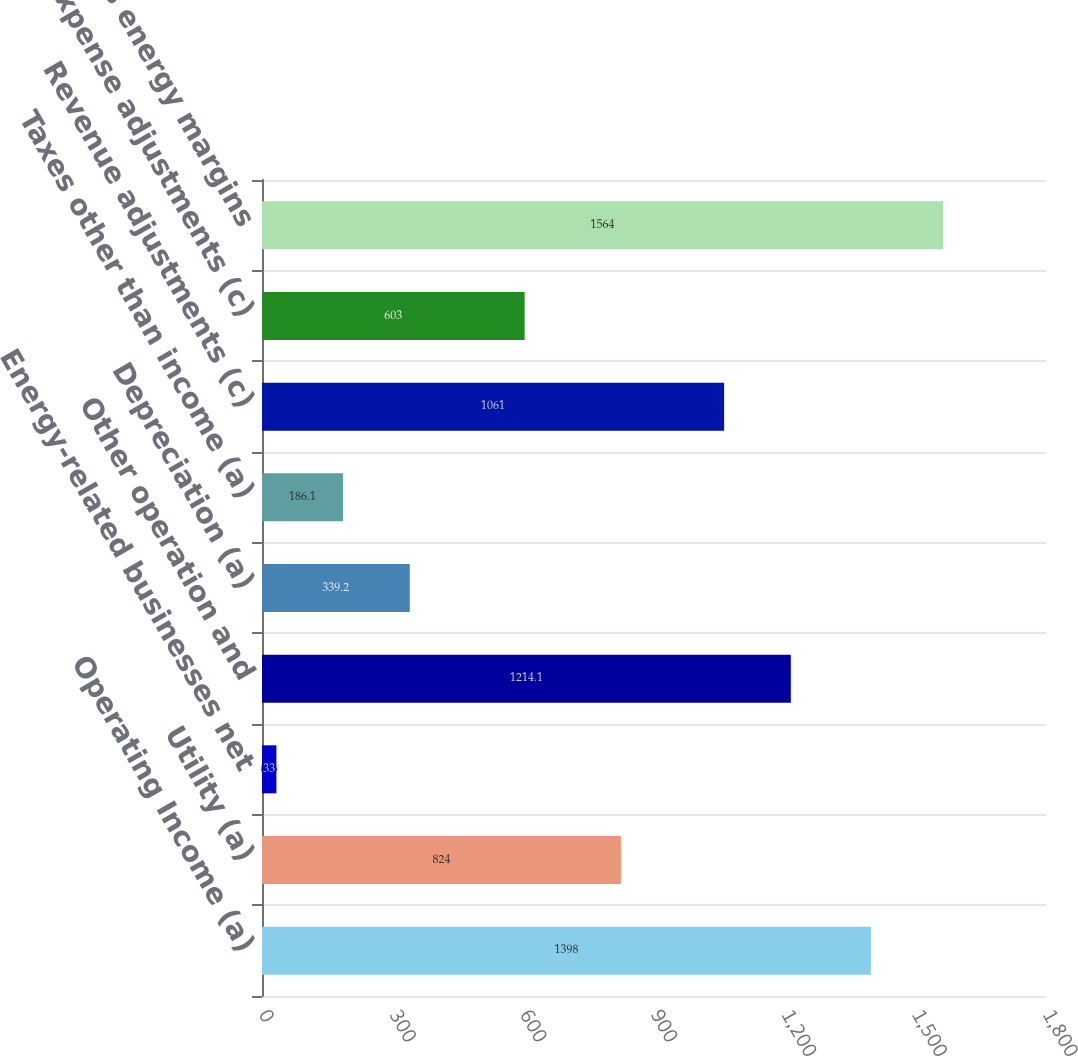<chart> <loc_0><loc_0><loc_500><loc_500><bar_chart><fcel>Operating Income (a)<fcel>Utility (a)<fcel>Energy-related businesses net<fcel>Other operation and<fcel>Depreciation (a)<fcel>Taxes other than income (a)<fcel>Revenue adjustments (c)<fcel>Expense adjustments (c)<fcel>Domestic gross energy margins<nl><fcel>1398<fcel>824<fcel>33<fcel>1214.1<fcel>339.2<fcel>186.1<fcel>1061<fcel>603<fcel>1564<nl></chart> 